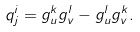<formula> <loc_0><loc_0><loc_500><loc_500>q ^ { i } _ { j } = g _ { u } ^ { k } g _ { v } ^ { l } - g ^ { l } _ { u } g ^ { k } _ { v } .</formula> 